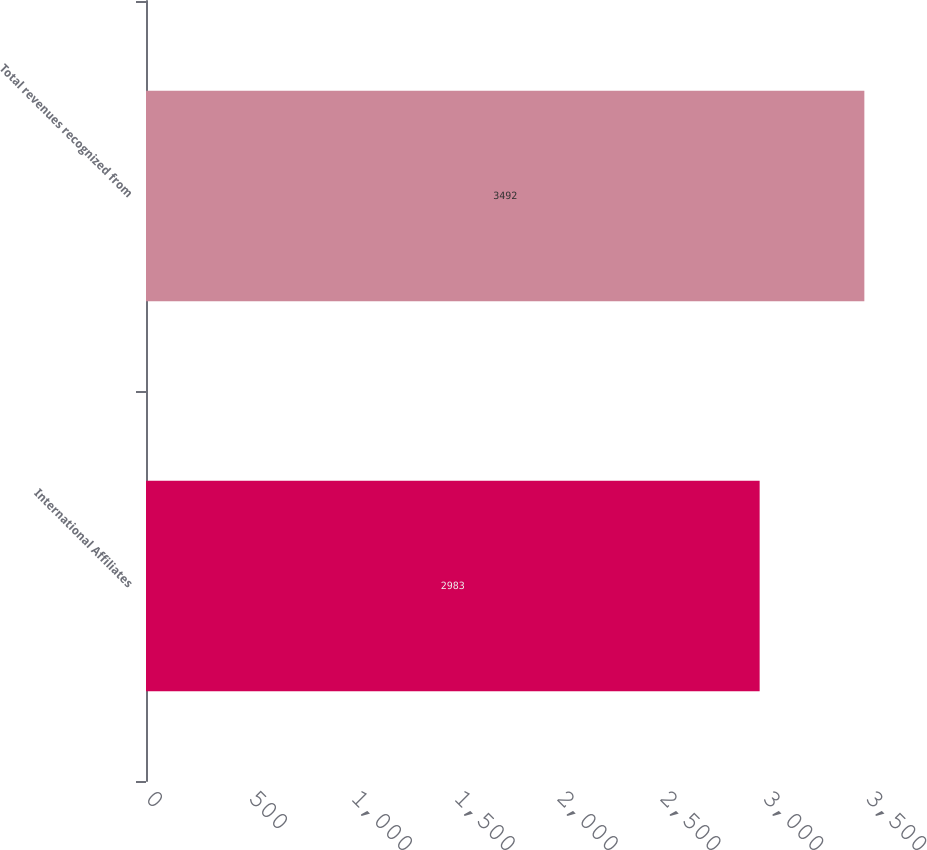<chart> <loc_0><loc_0><loc_500><loc_500><bar_chart><fcel>International Affiliates<fcel>Total revenues recognized from<nl><fcel>2983<fcel>3492<nl></chart> 